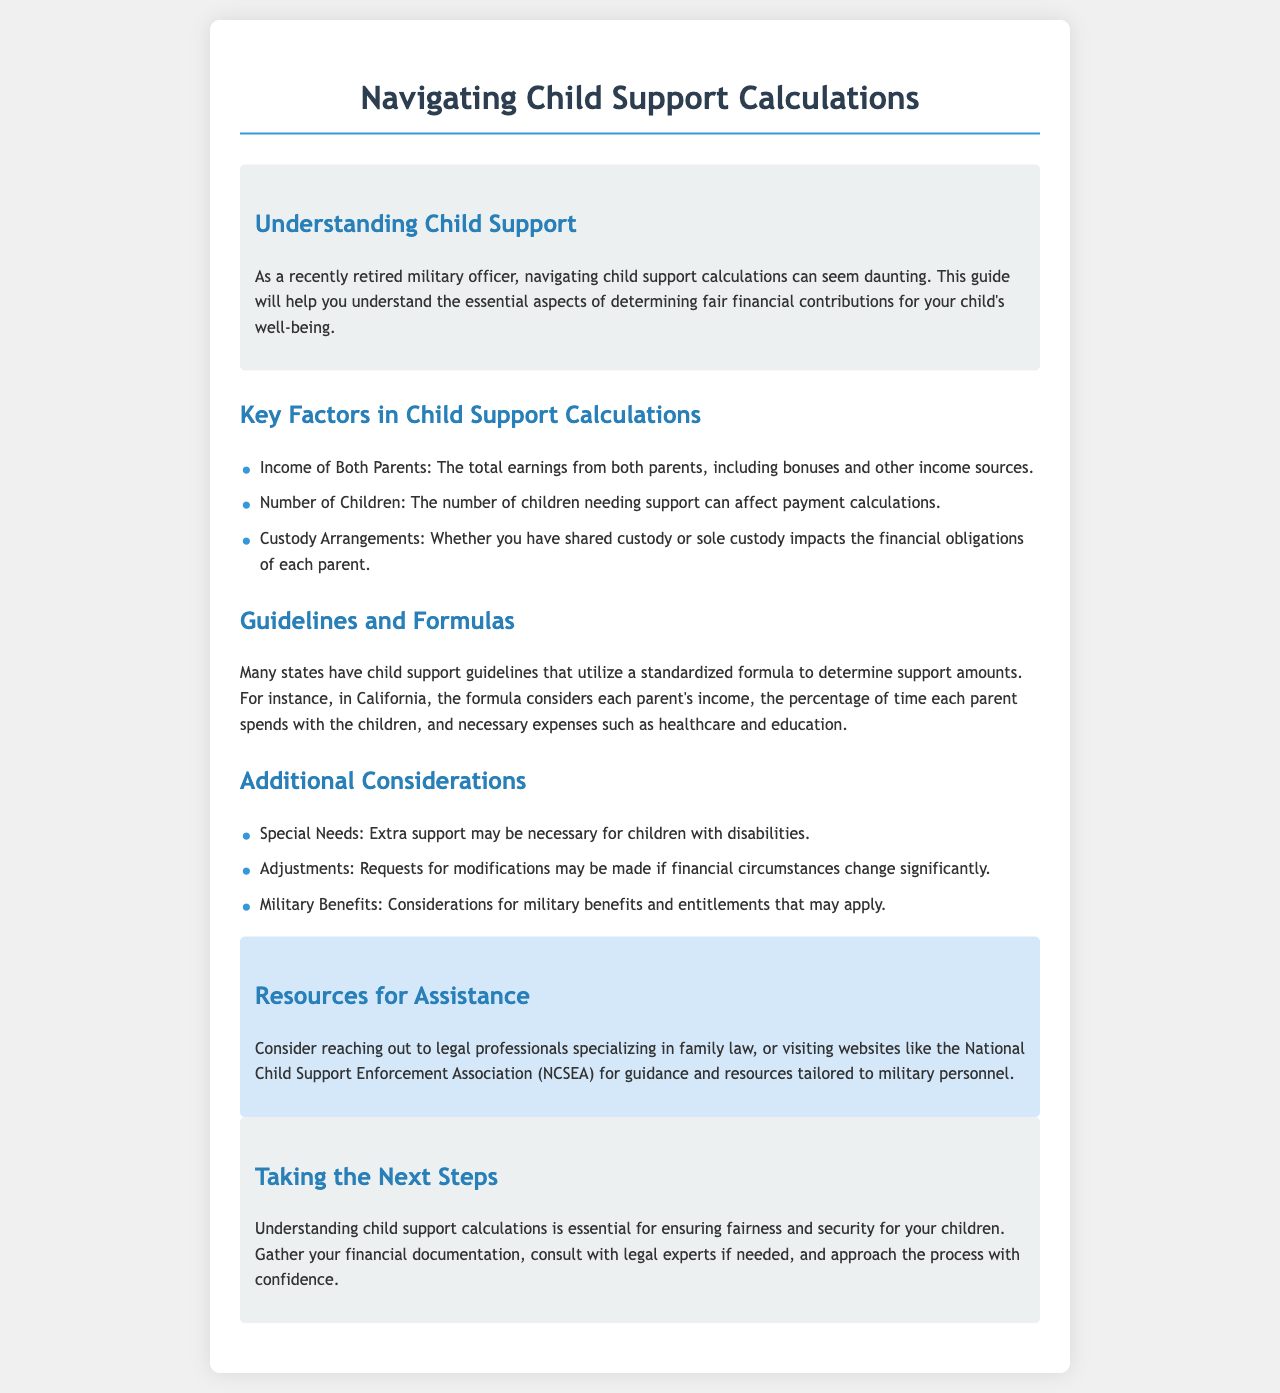What are the key factors in child support calculations? The document outlines three key factors: income of both parents, number of children, and custody arrangements.
Answer: Income of Both Parents, Number of Children, Custody Arrangements What does the California support formula consider? The document specifies that the California formula considers each parent's income, time spent with children, and necessary expenses.
Answer: Each parent's income, percentage of time spent with children, necessary expenses What additional consideration is mentioned for children with disabilities? The document indicates that extra support may be necessary for children with disabilities.
Answer: Extra support What type of professionals can provide assistance? The document suggests reaching out to legal professionals specializing in family law for assistance.
Answer: Legal professionals specializing in family law What can modifications in support be requested for? The document states that adjustments can be requested if financial circumstances change significantly.
Answer: Financial circumstances change What organization is mentioned for guidance related to child support? The document mentions the National Child Support Enforcement Association (NCSEA) for guidance and resources.
Answer: National Child Support Enforcement Association (NCSEA) What is advised to gather before approaching the child support process? The document advises gathering financial documentation before proceeding.
Answer: Financial documentation 